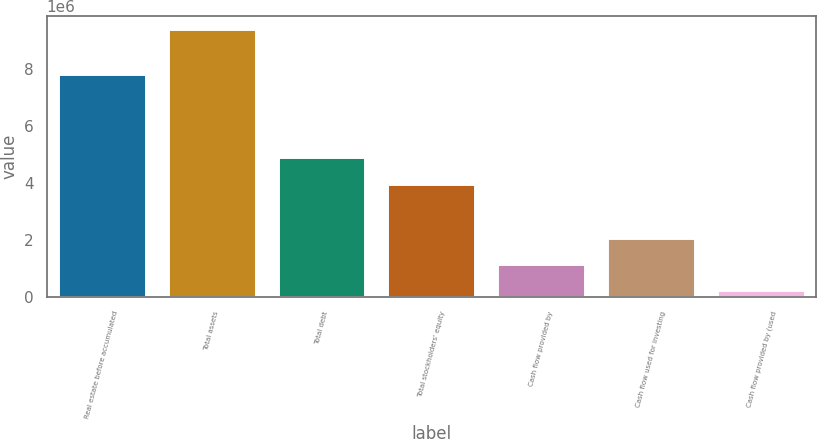Convert chart to OTSL. <chart><loc_0><loc_0><loc_500><loc_500><bar_chart><fcel>Real estate before accumulated<fcel>Total assets<fcel>Total debt<fcel>Total stockholders' equity<fcel>Cash flow provided by<fcel>Cash flow used for investing<fcel>Cash flow provided by (used<nl><fcel>7.81892e+06<fcel>9.39715e+06<fcel>4.89717e+06<fcel>3.9837e+06<fcel>1.1759e+06<fcel>2.08937e+06<fcel>262429<nl></chart> 